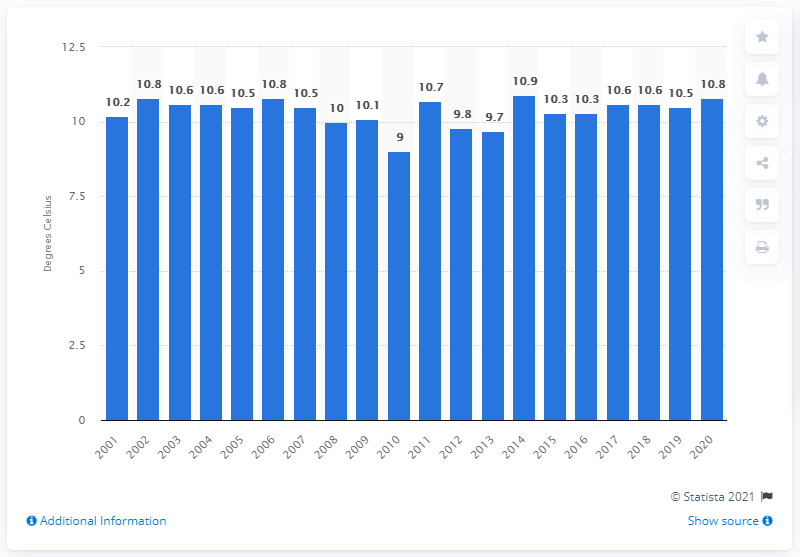List a handful of essential elements in this visual. In 2020, the UK experienced an average daily temperature of 10.8 degrees Celsius. 